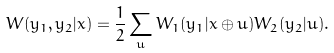<formula> <loc_0><loc_0><loc_500><loc_500>W ( y _ { 1 } , y _ { 2 } | x ) = \frac { 1 } { 2 } \sum _ { u } W _ { 1 } ( y _ { 1 } | x \oplus u ) W _ { 2 } ( y _ { 2 } | u ) .</formula> 